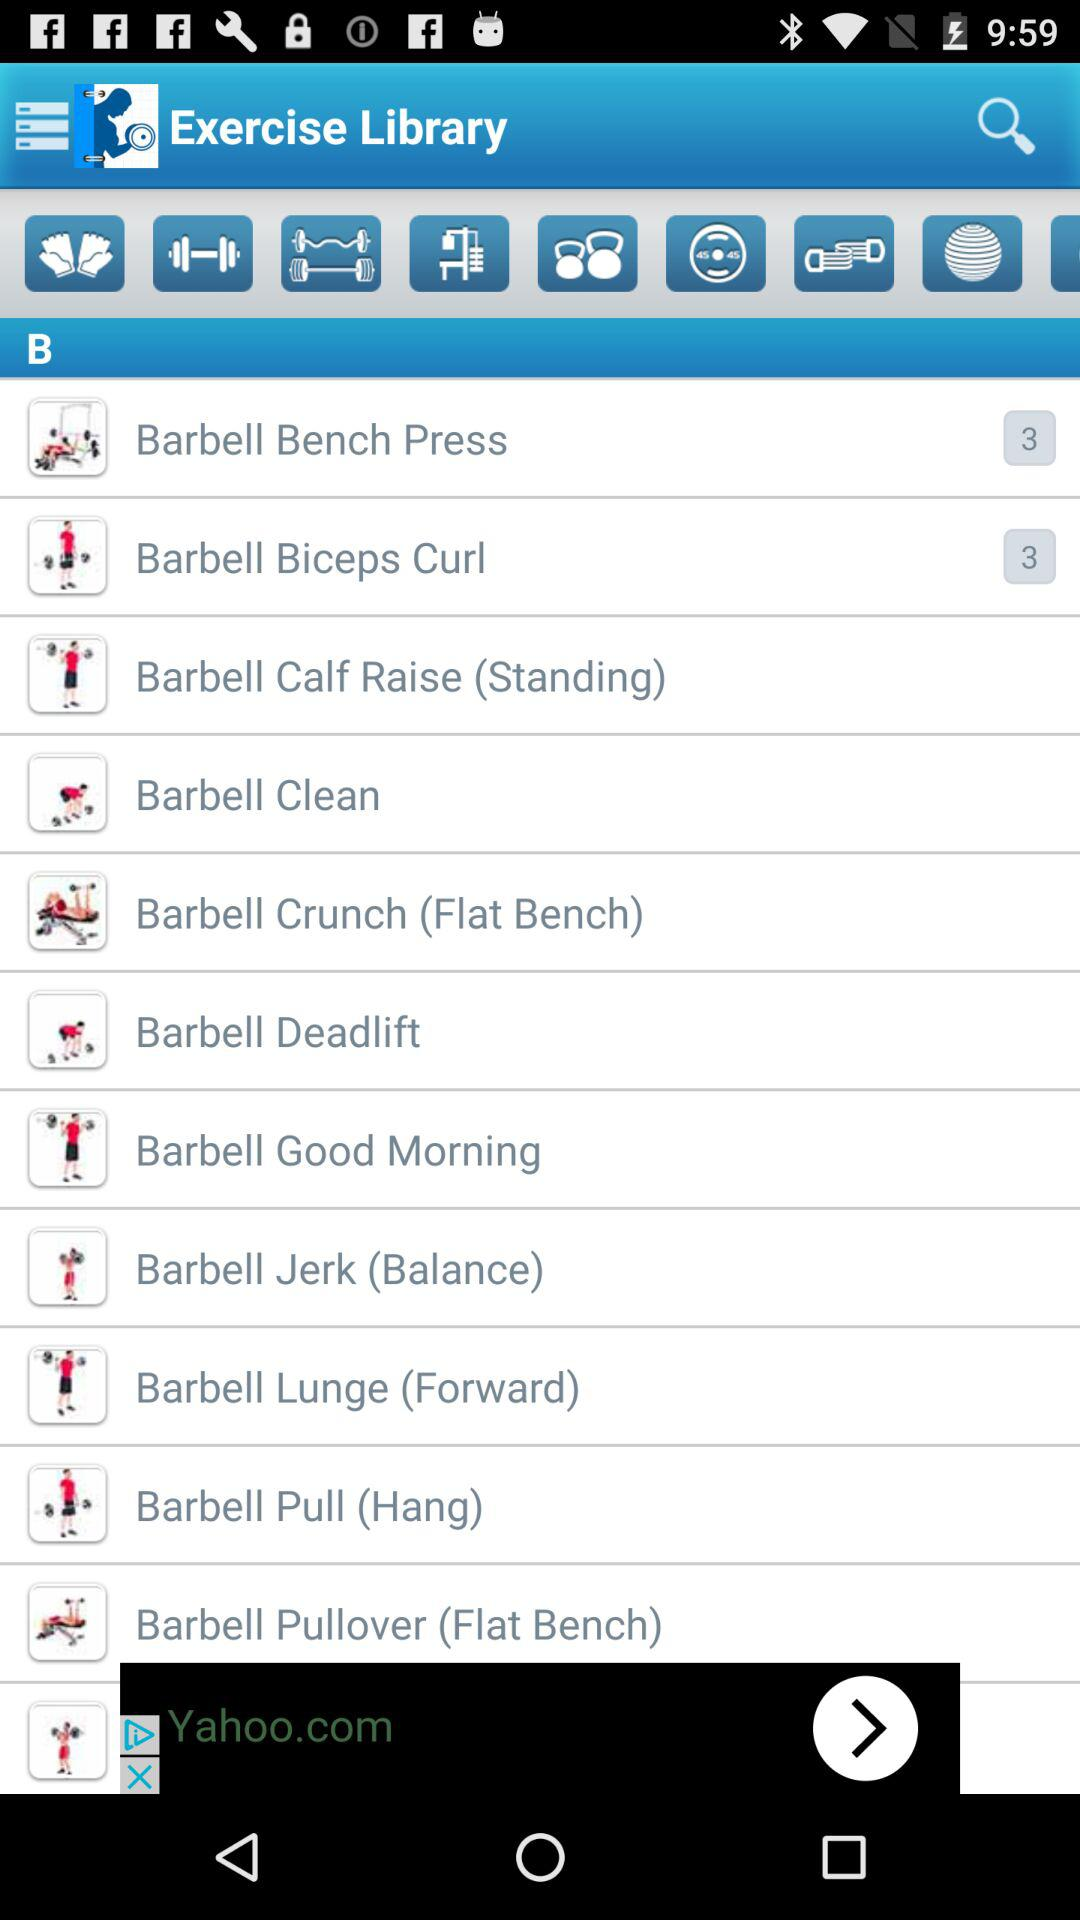What is the number mentioned in "Barbell Bench Press"? The number mentioned in "Barbell Bench Press" is 3. 